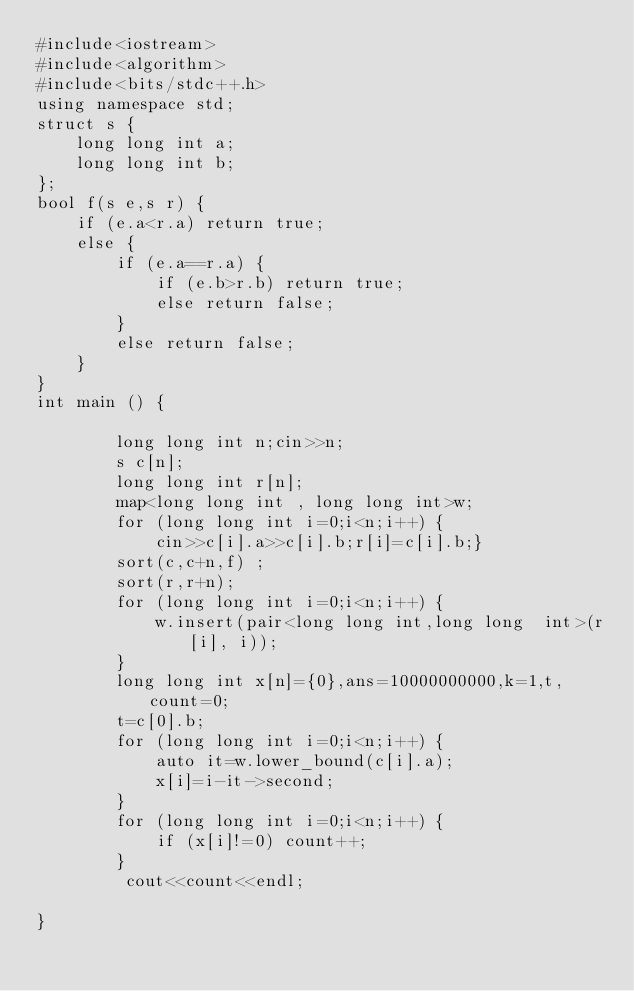Convert code to text. <code><loc_0><loc_0><loc_500><loc_500><_C++_>#include<iostream>
#include<algorithm>
#include<bits/stdc++.h>
using namespace std;
struct s {
    long long int a;
    long long int b;
};
bool f(s e,s r) {
    if (e.a<r.a) return true;
    else {
        if (e.a==r.a) {
            if (e.b>r.b) return true;
            else return false;
        }
        else return false;
    }
}
int main () {
     
        long long int n;cin>>n;
        s c[n];
        long long int r[n];
        map<long long int , long long int>w;
        for (long long int i=0;i<n;i++) { 
            cin>>c[i].a>>c[i].b;r[i]=c[i].b;}
        sort(c,c+n,f) ;
        sort(r,r+n);
        for (long long int i=0;i<n;i++) {
            w.insert(pair<long long int,long long  int>(r[i], i));
        }
        long long int x[n]={0},ans=10000000000,k=1,t,count=0;
        t=c[0].b;
        for (long long int i=0;i<n;i++) {
            auto it=w.lower_bound(c[i].a);
            x[i]=i-it->second;
        }
        for (long long int i=0;i<n;i++) {
            if (x[i]!=0) count++;
        }
         cout<<count<<endl;
    
}</code> 